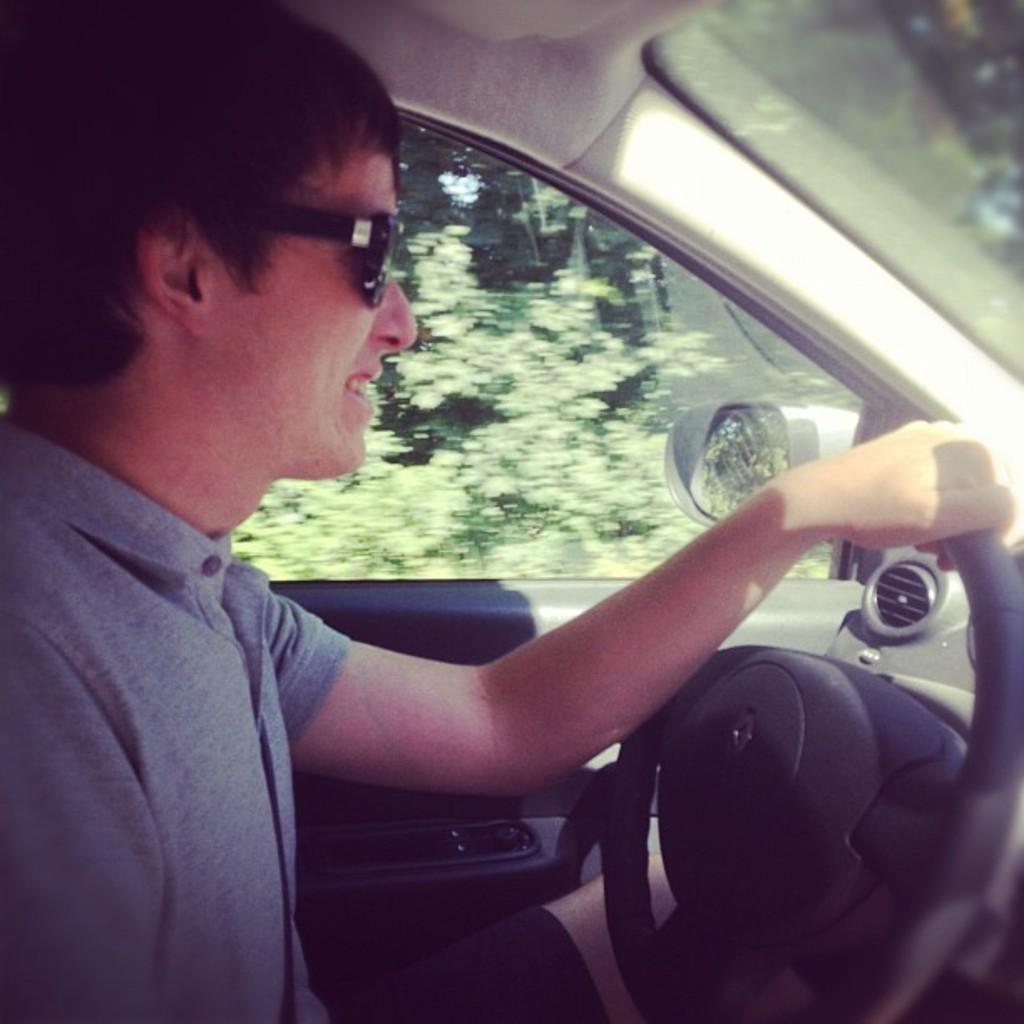In one or two sentences, can you explain what this image depicts? In this image we can see a man wearing specs is holding a steering of a car. In the back there are trees. 